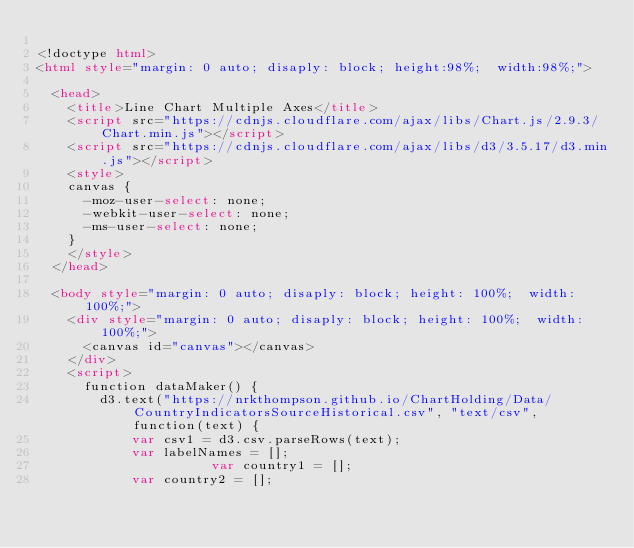Convert code to text. <code><loc_0><loc_0><loc_500><loc_500><_HTML_>
<!doctype html>
<html style="margin: 0 auto; disaply: block; height:98%;  width:98%;">

	<head>
		<title>Line Chart Multiple Axes</title>
		<script src="https://cdnjs.cloudflare.com/ajax/libs/Chart.js/2.9.3/Chart.min.js"></script>
		<script src="https://cdnjs.cloudflare.com/ajax/libs/d3/3.5.17/d3.min.js"></script>
		<style>
		canvas {
			-moz-user-select: none;
			-webkit-user-select: none;
			-ms-user-select: none;
		}
		</style>
	</head>

	<body style="margin: 0 auto; disaply: block; height: 100%;  width: 100%;">
		<div style="margin: 0 auto; disaply: block; height: 100%;  width: 100%;">
			<canvas id="canvas"></canvas>
		</div>
		<script>
			function dataMaker() {
				d3.text("https://nrkthompson.github.io/ChartHolding/Data/CountryIndicatorsSourceHistorical.csv", "text/csv", function(text) {
					  var csv1 = d3.csv.parseRows(text);
					  var labelNames = [];
            				  var country1 = [];
					  var country2 = [];</code> 